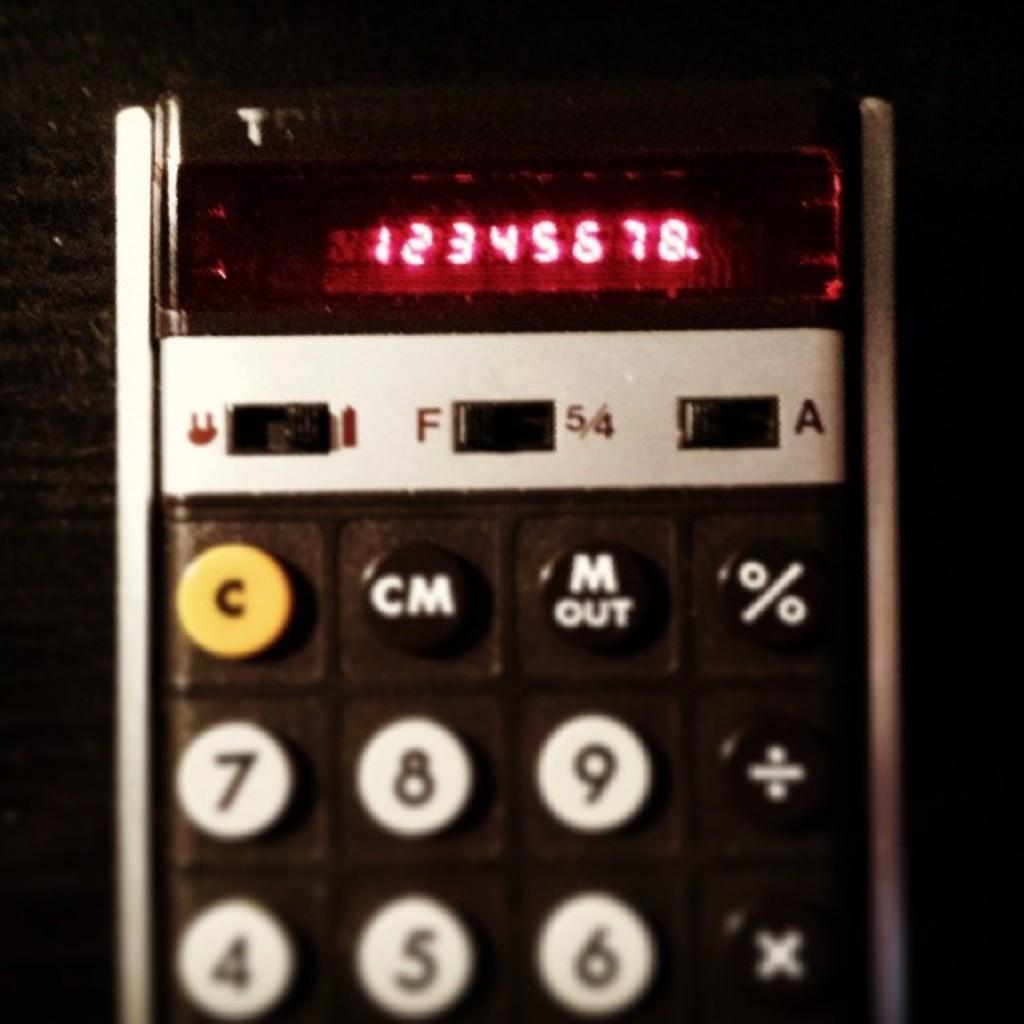What is this device called?
Offer a terse response. Calculator. 